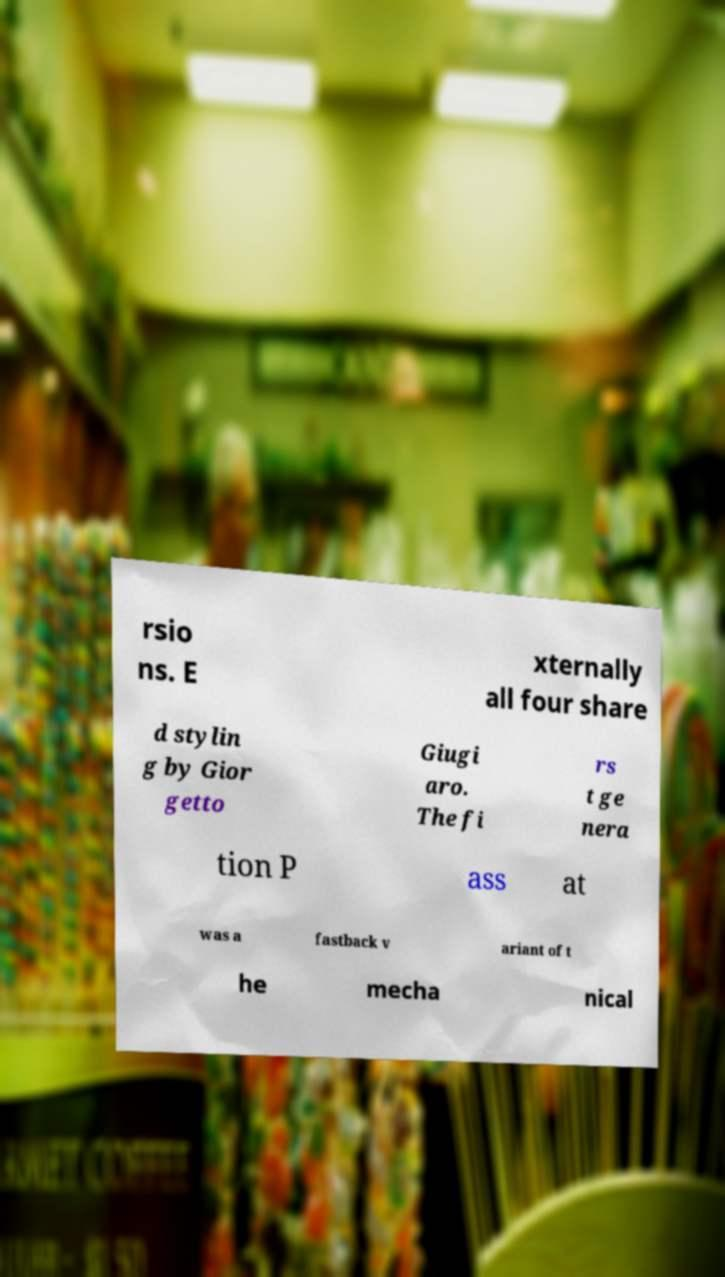For documentation purposes, I need the text within this image transcribed. Could you provide that? rsio ns. E xternally all four share d stylin g by Gior getto Giugi aro. The fi rs t ge nera tion P ass at was a fastback v ariant of t he mecha nical 